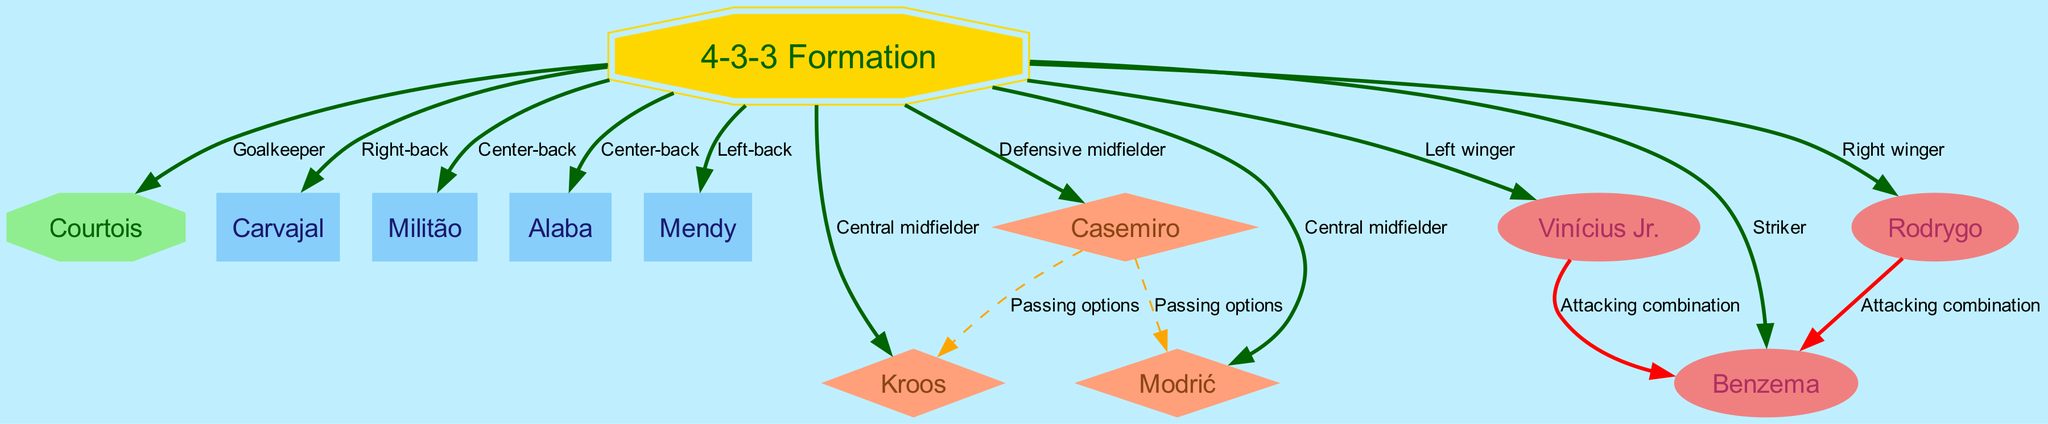What is the role of Courtois in the 4-3-3 Formation? In the diagram, Courtois is directly connected to the "4-3-3 Formation" node with the label "Goalkeeper," indicating that his position is that of the goalkeeper in this formation.
Answer: Goalkeeper How many nodes are in the diagram? The diagram contains 11 nodes listed under the "nodes" key in the data, which represents the players and formation used by Real Madrid.
Answer: 11 Which player is designated as the right winger? The directed edge from the "4-3-3 Formation" node to "Rodrygo" is labeled "Right winger," indicating that Rodrygo's designated position is as the right winger.
Answer: Rodrygo What type of edge connects Casemiro to Kroos? The diagram shows a dashed line labeled "Passing options," which illustrates that there's a passing option relationship between Casemiro and Kroos within the midfield setup.
Answer: Passing options Which players are involved in attacking combinations with Benzema? The directed edges labeled "Attacking combination" connect both "Vinícius Jr." and "Rodrygo" to "Benzema," meaning both players collaborate with Benzema in attacking plays.
Answer: Vinícius Jr. and Rodrygo What is the formation used by Real Madrid in this diagram? The "4-3-3 Formation" is explicitly stated as the central node, which represents the tactical shape that Real Madrid employs in the match according to the diagram.
Answer: 4-3-3 Formation What is the relationship between Vinícius Jr. and Benzema? The diagram illustrates an edge labeled "Attacking combination" from "Vinícius Jr." to "Benzema," indicating their collaboration during attacking plays in matches.
Answer: Attacking combination How many defensive midfielders are there in the formation? The central node shows that there is one defensive midfielder linked to the formation, which is Casemiro, making the count of defensive midfielders one in this setup.
Answer: 1 Which three players are categorized as central midfielders? The nodes "Kroos," "Casemiro," and "Modrić" are related to the "4-3-3 Formation," but only 2 of them, Kroos and Modrić, are classified as central midfielders as shown in the diagram's edge labels.
Answer: Kroos and Modrić 